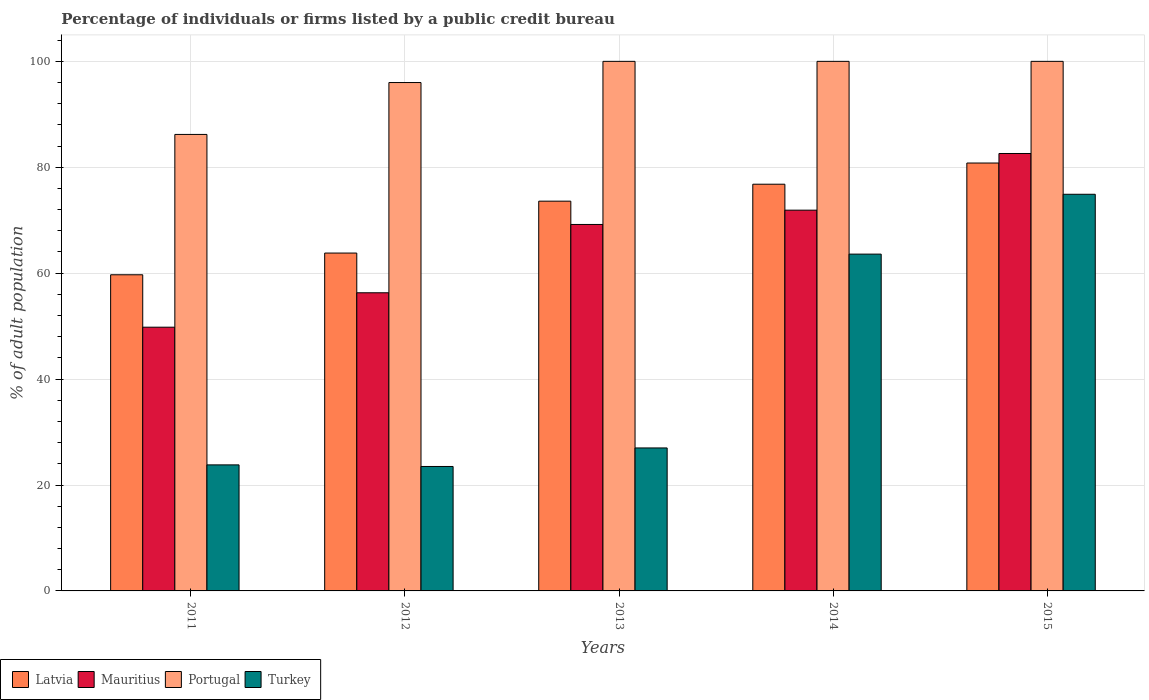How many different coloured bars are there?
Your response must be concise. 4. Are the number of bars per tick equal to the number of legend labels?
Ensure brevity in your answer.  Yes. Are the number of bars on each tick of the X-axis equal?
Your response must be concise. Yes. How many bars are there on the 3rd tick from the left?
Offer a terse response. 4. What is the label of the 1st group of bars from the left?
Your answer should be compact. 2011. In how many cases, is the number of bars for a given year not equal to the number of legend labels?
Provide a short and direct response. 0. What is the percentage of population listed by a public credit bureau in Turkey in 2014?
Your answer should be compact. 63.6. Across all years, what is the minimum percentage of population listed by a public credit bureau in Turkey?
Your response must be concise. 23.5. In which year was the percentage of population listed by a public credit bureau in Turkey maximum?
Give a very brief answer. 2015. In which year was the percentage of population listed by a public credit bureau in Turkey minimum?
Offer a very short reply. 2012. What is the total percentage of population listed by a public credit bureau in Mauritius in the graph?
Your response must be concise. 329.8. What is the difference between the percentage of population listed by a public credit bureau in Portugal in 2013 and that in 2015?
Give a very brief answer. 0. What is the difference between the percentage of population listed by a public credit bureau in Turkey in 2011 and the percentage of population listed by a public credit bureau in Mauritius in 2014?
Your answer should be compact. -48.1. What is the average percentage of population listed by a public credit bureau in Latvia per year?
Keep it short and to the point. 70.94. In the year 2012, what is the difference between the percentage of population listed by a public credit bureau in Latvia and percentage of population listed by a public credit bureau in Portugal?
Give a very brief answer. -32.2. What is the ratio of the percentage of population listed by a public credit bureau in Latvia in 2014 to that in 2015?
Offer a terse response. 0.95. What is the difference between the highest and the second highest percentage of population listed by a public credit bureau in Mauritius?
Provide a succinct answer. 10.7. What is the difference between the highest and the lowest percentage of population listed by a public credit bureau in Portugal?
Keep it short and to the point. 13.8. Is it the case that in every year, the sum of the percentage of population listed by a public credit bureau in Mauritius and percentage of population listed by a public credit bureau in Latvia is greater than the sum of percentage of population listed by a public credit bureau in Turkey and percentage of population listed by a public credit bureau in Portugal?
Your response must be concise. No. What does the 3rd bar from the left in 2013 represents?
Offer a very short reply. Portugal. What does the 2nd bar from the right in 2013 represents?
Your answer should be compact. Portugal. How many bars are there?
Your answer should be very brief. 20. Are all the bars in the graph horizontal?
Offer a terse response. No. What is the difference between two consecutive major ticks on the Y-axis?
Ensure brevity in your answer.  20. Are the values on the major ticks of Y-axis written in scientific E-notation?
Keep it short and to the point. No. How are the legend labels stacked?
Offer a terse response. Horizontal. What is the title of the graph?
Keep it short and to the point. Percentage of individuals or firms listed by a public credit bureau. Does "Central African Republic" appear as one of the legend labels in the graph?
Offer a very short reply. No. What is the label or title of the X-axis?
Offer a terse response. Years. What is the label or title of the Y-axis?
Offer a very short reply. % of adult population. What is the % of adult population in Latvia in 2011?
Your answer should be compact. 59.7. What is the % of adult population in Mauritius in 2011?
Make the answer very short. 49.8. What is the % of adult population in Portugal in 2011?
Offer a terse response. 86.2. What is the % of adult population in Turkey in 2011?
Your answer should be compact. 23.8. What is the % of adult population of Latvia in 2012?
Provide a short and direct response. 63.8. What is the % of adult population in Mauritius in 2012?
Provide a short and direct response. 56.3. What is the % of adult population in Portugal in 2012?
Provide a short and direct response. 96. What is the % of adult population of Latvia in 2013?
Provide a succinct answer. 73.6. What is the % of adult population in Mauritius in 2013?
Give a very brief answer. 69.2. What is the % of adult population of Latvia in 2014?
Your answer should be very brief. 76.8. What is the % of adult population of Mauritius in 2014?
Your answer should be very brief. 71.9. What is the % of adult population in Portugal in 2014?
Offer a very short reply. 100. What is the % of adult population of Turkey in 2014?
Provide a short and direct response. 63.6. What is the % of adult population in Latvia in 2015?
Your answer should be compact. 80.8. What is the % of adult population in Mauritius in 2015?
Your answer should be very brief. 82.6. What is the % of adult population in Portugal in 2015?
Keep it short and to the point. 100. What is the % of adult population in Turkey in 2015?
Your answer should be compact. 74.9. Across all years, what is the maximum % of adult population of Latvia?
Offer a terse response. 80.8. Across all years, what is the maximum % of adult population of Mauritius?
Your response must be concise. 82.6. Across all years, what is the maximum % of adult population in Turkey?
Ensure brevity in your answer.  74.9. Across all years, what is the minimum % of adult population of Latvia?
Your answer should be compact. 59.7. Across all years, what is the minimum % of adult population of Mauritius?
Offer a very short reply. 49.8. Across all years, what is the minimum % of adult population in Portugal?
Your answer should be compact. 86.2. What is the total % of adult population of Latvia in the graph?
Give a very brief answer. 354.7. What is the total % of adult population in Mauritius in the graph?
Keep it short and to the point. 329.8. What is the total % of adult population in Portugal in the graph?
Give a very brief answer. 482.2. What is the total % of adult population of Turkey in the graph?
Keep it short and to the point. 212.8. What is the difference between the % of adult population in Turkey in 2011 and that in 2012?
Keep it short and to the point. 0.3. What is the difference between the % of adult population of Latvia in 2011 and that in 2013?
Your answer should be compact. -13.9. What is the difference between the % of adult population of Mauritius in 2011 and that in 2013?
Offer a terse response. -19.4. What is the difference between the % of adult population in Turkey in 2011 and that in 2013?
Give a very brief answer. -3.2. What is the difference between the % of adult population of Latvia in 2011 and that in 2014?
Your answer should be very brief. -17.1. What is the difference between the % of adult population in Mauritius in 2011 and that in 2014?
Provide a succinct answer. -22.1. What is the difference between the % of adult population in Portugal in 2011 and that in 2014?
Keep it short and to the point. -13.8. What is the difference between the % of adult population in Turkey in 2011 and that in 2014?
Give a very brief answer. -39.8. What is the difference between the % of adult population of Latvia in 2011 and that in 2015?
Your answer should be compact. -21.1. What is the difference between the % of adult population of Mauritius in 2011 and that in 2015?
Your answer should be very brief. -32.8. What is the difference between the % of adult population in Portugal in 2011 and that in 2015?
Give a very brief answer. -13.8. What is the difference between the % of adult population of Turkey in 2011 and that in 2015?
Offer a very short reply. -51.1. What is the difference between the % of adult population in Latvia in 2012 and that in 2014?
Offer a terse response. -13. What is the difference between the % of adult population in Mauritius in 2012 and that in 2014?
Make the answer very short. -15.6. What is the difference between the % of adult population in Portugal in 2012 and that in 2014?
Provide a short and direct response. -4. What is the difference between the % of adult population in Turkey in 2012 and that in 2014?
Make the answer very short. -40.1. What is the difference between the % of adult population in Mauritius in 2012 and that in 2015?
Make the answer very short. -26.3. What is the difference between the % of adult population in Turkey in 2012 and that in 2015?
Make the answer very short. -51.4. What is the difference between the % of adult population of Portugal in 2013 and that in 2014?
Give a very brief answer. 0. What is the difference between the % of adult population of Turkey in 2013 and that in 2014?
Your response must be concise. -36.6. What is the difference between the % of adult population of Latvia in 2013 and that in 2015?
Provide a short and direct response. -7.2. What is the difference between the % of adult population of Turkey in 2013 and that in 2015?
Your answer should be very brief. -47.9. What is the difference between the % of adult population in Portugal in 2014 and that in 2015?
Offer a terse response. 0. What is the difference between the % of adult population of Latvia in 2011 and the % of adult population of Mauritius in 2012?
Provide a succinct answer. 3.4. What is the difference between the % of adult population in Latvia in 2011 and the % of adult population in Portugal in 2012?
Provide a succinct answer. -36.3. What is the difference between the % of adult population of Latvia in 2011 and the % of adult population of Turkey in 2012?
Offer a very short reply. 36.2. What is the difference between the % of adult population in Mauritius in 2011 and the % of adult population in Portugal in 2012?
Keep it short and to the point. -46.2. What is the difference between the % of adult population in Mauritius in 2011 and the % of adult population in Turkey in 2012?
Make the answer very short. 26.3. What is the difference between the % of adult population in Portugal in 2011 and the % of adult population in Turkey in 2012?
Keep it short and to the point. 62.7. What is the difference between the % of adult population in Latvia in 2011 and the % of adult population in Mauritius in 2013?
Offer a terse response. -9.5. What is the difference between the % of adult population in Latvia in 2011 and the % of adult population in Portugal in 2013?
Your answer should be very brief. -40.3. What is the difference between the % of adult population in Latvia in 2011 and the % of adult population in Turkey in 2013?
Ensure brevity in your answer.  32.7. What is the difference between the % of adult population in Mauritius in 2011 and the % of adult population in Portugal in 2013?
Offer a terse response. -50.2. What is the difference between the % of adult population of Mauritius in 2011 and the % of adult population of Turkey in 2013?
Your answer should be compact. 22.8. What is the difference between the % of adult population of Portugal in 2011 and the % of adult population of Turkey in 2013?
Provide a short and direct response. 59.2. What is the difference between the % of adult population in Latvia in 2011 and the % of adult population in Mauritius in 2014?
Your answer should be very brief. -12.2. What is the difference between the % of adult population in Latvia in 2011 and the % of adult population in Portugal in 2014?
Your response must be concise. -40.3. What is the difference between the % of adult population of Mauritius in 2011 and the % of adult population of Portugal in 2014?
Make the answer very short. -50.2. What is the difference between the % of adult population of Portugal in 2011 and the % of adult population of Turkey in 2014?
Your response must be concise. 22.6. What is the difference between the % of adult population in Latvia in 2011 and the % of adult population in Mauritius in 2015?
Your response must be concise. -22.9. What is the difference between the % of adult population of Latvia in 2011 and the % of adult population of Portugal in 2015?
Give a very brief answer. -40.3. What is the difference between the % of adult population of Latvia in 2011 and the % of adult population of Turkey in 2015?
Offer a terse response. -15.2. What is the difference between the % of adult population of Mauritius in 2011 and the % of adult population of Portugal in 2015?
Provide a succinct answer. -50.2. What is the difference between the % of adult population of Mauritius in 2011 and the % of adult population of Turkey in 2015?
Your answer should be compact. -25.1. What is the difference between the % of adult population in Latvia in 2012 and the % of adult population in Mauritius in 2013?
Provide a succinct answer. -5.4. What is the difference between the % of adult population in Latvia in 2012 and the % of adult population in Portugal in 2013?
Your answer should be very brief. -36.2. What is the difference between the % of adult population in Latvia in 2012 and the % of adult population in Turkey in 2013?
Provide a succinct answer. 36.8. What is the difference between the % of adult population in Mauritius in 2012 and the % of adult population in Portugal in 2013?
Provide a succinct answer. -43.7. What is the difference between the % of adult population of Mauritius in 2012 and the % of adult population of Turkey in 2013?
Provide a succinct answer. 29.3. What is the difference between the % of adult population of Latvia in 2012 and the % of adult population of Portugal in 2014?
Provide a succinct answer. -36.2. What is the difference between the % of adult population in Latvia in 2012 and the % of adult population in Turkey in 2014?
Offer a very short reply. 0.2. What is the difference between the % of adult population of Mauritius in 2012 and the % of adult population of Portugal in 2014?
Provide a short and direct response. -43.7. What is the difference between the % of adult population of Portugal in 2012 and the % of adult population of Turkey in 2014?
Your answer should be very brief. 32.4. What is the difference between the % of adult population of Latvia in 2012 and the % of adult population of Mauritius in 2015?
Your response must be concise. -18.8. What is the difference between the % of adult population of Latvia in 2012 and the % of adult population of Portugal in 2015?
Your answer should be compact. -36.2. What is the difference between the % of adult population of Mauritius in 2012 and the % of adult population of Portugal in 2015?
Make the answer very short. -43.7. What is the difference between the % of adult population in Mauritius in 2012 and the % of adult population in Turkey in 2015?
Make the answer very short. -18.6. What is the difference between the % of adult population of Portugal in 2012 and the % of adult population of Turkey in 2015?
Your answer should be very brief. 21.1. What is the difference between the % of adult population in Latvia in 2013 and the % of adult population in Portugal in 2014?
Offer a very short reply. -26.4. What is the difference between the % of adult population of Latvia in 2013 and the % of adult population of Turkey in 2014?
Provide a short and direct response. 10. What is the difference between the % of adult population in Mauritius in 2013 and the % of adult population in Portugal in 2014?
Keep it short and to the point. -30.8. What is the difference between the % of adult population of Mauritius in 2013 and the % of adult population of Turkey in 2014?
Your response must be concise. 5.6. What is the difference between the % of adult population in Portugal in 2013 and the % of adult population in Turkey in 2014?
Give a very brief answer. 36.4. What is the difference between the % of adult population of Latvia in 2013 and the % of adult population of Portugal in 2015?
Offer a very short reply. -26.4. What is the difference between the % of adult population in Latvia in 2013 and the % of adult population in Turkey in 2015?
Offer a very short reply. -1.3. What is the difference between the % of adult population in Mauritius in 2013 and the % of adult population in Portugal in 2015?
Keep it short and to the point. -30.8. What is the difference between the % of adult population of Portugal in 2013 and the % of adult population of Turkey in 2015?
Give a very brief answer. 25.1. What is the difference between the % of adult population in Latvia in 2014 and the % of adult population in Portugal in 2015?
Ensure brevity in your answer.  -23.2. What is the difference between the % of adult population of Latvia in 2014 and the % of adult population of Turkey in 2015?
Provide a short and direct response. 1.9. What is the difference between the % of adult population in Mauritius in 2014 and the % of adult population in Portugal in 2015?
Provide a short and direct response. -28.1. What is the difference between the % of adult population of Mauritius in 2014 and the % of adult population of Turkey in 2015?
Your answer should be compact. -3. What is the difference between the % of adult population of Portugal in 2014 and the % of adult population of Turkey in 2015?
Offer a very short reply. 25.1. What is the average % of adult population in Latvia per year?
Your answer should be very brief. 70.94. What is the average % of adult population in Mauritius per year?
Make the answer very short. 65.96. What is the average % of adult population in Portugal per year?
Your answer should be very brief. 96.44. What is the average % of adult population in Turkey per year?
Your answer should be very brief. 42.56. In the year 2011, what is the difference between the % of adult population in Latvia and % of adult population in Mauritius?
Give a very brief answer. 9.9. In the year 2011, what is the difference between the % of adult population of Latvia and % of adult population of Portugal?
Give a very brief answer. -26.5. In the year 2011, what is the difference between the % of adult population in Latvia and % of adult population in Turkey?
Offer a very short reply. 35.9. In the year 2011, what is the difference between the % of adult population of Mauritius and % of adult population of Portugal?
Offer a terse response. -36.4. In the year 2011, what is the difference between the % of adult population of Portugal and % of adult population of Turkey?
Your answer should be very brief. 62.4. In the year 2012, what is the difference between the % of adult population of Latvia and % of adult population of Mauritius?
Offer a very short reply. 7.5. In the year 2012, what is the difference between the % of adult population in Latvia and % of adult population in Portugal?
Offer a terse response. -32.2. In the year 2012, what is the difference between the % of adult population in Latvia and % of adult population in Turkey?
Keep it short and to the point. 40.3. In the year 2012, what is the difference between the % of adult population in Mauritius and % of adult population in Portugal?
Ensure brevity in your answer.  -39.7. In the year 2012, what is the difference between the % of adult population in Mauritius and % of adult population in Turkey?
Provide a succinct answer. 32.8. In the year 2012, what is the difference between the % of adult population in Portugal and % of adult population in Turkey?
Provide a succinct answer. 72.5. In the year 2013, what is the difference between the % of adult population in Latvia and % of adult population in Portugal?
Keep it short and to the point. -26.4. In the year 2013, what is the difference between the % of adult population of Latvia and % of adult population of Turkey?
Offer a very short reply. 46.6. In the year 2013, what is the difference between the % of adult population of Mauritius and % of adult population of Portugal?
Ensure brevity in your answer.  -30.8. In the year 2013, what is the difference between the % of adult population of Mauritius and % of adult population of Turkey?
Make the answer very short. 42.2. In the year 2014, what is the difference between the % of adult population in Latvia and % of adult population in Mauritius?
Keep it short and to the point. 4.9. In the year 2014, what is the difference between the % of adult population in Latvia and % of adult population in Portugal?
Keep it short and to the point. -23.2. In the year 2014, what is the difference between the % of adult population of Mauritius and % of adult population of Portugal?
Give a very brief answer. -28.1. In the year 2014, what is the difference between the % of adult population in Mauritius and % of adult population in Turkey?
Your answer should be compact. 8.3. In the year 2014, what is the difference between the % of adult population of Portugal and % of adult population of Turkey?
Your answer should be compact. 36.4. In the year 2015, what is the difference between the % of adult population in Latvia and % of adult population in Portugal?
Ensure brevity in your answer.  -19.2. In the year 2015, what is the difference between the % of adult population of Latvia and % of adult population of Turkey?
Provide a short and direct response. 5.9. In the year 2015, what is the difference between the % of adult population of Mauritius and % of adult population of Portugal?
Keep it short and to the point. -17.4. In the year 2015, what is the difference between the % of adult population in Portugal and % of adult population in Turkey?
Keep it short and to the point. 25.1. What is the ratio of the % of adult population of Latvia in 2011 to that in 2012?
Your response must be concise. 0.94. What is the ratio of the % of adult population of Mauritius in 2011 to that in 2012?
Your response must be concise. 0.88. What is the ratio of the % of adult population of Portugal in 2011 to that in 2012?
Provide a short and direct response. 0.9. What is the ratio of the % of adult population of Turkey in 2011 to that in 2012?
Offer a terse response. 1.01. What is the ratio of the % of adult population of Latvia in 2011 to that in 2013?
Ensure brevity in your answer.  0.81. What is the ratio of the % of adult population of Mauritius in 2011 to that in 2013?
Your answer should be very brief. 0.72. What is the ratio of the % of adult population in Portugal in 2011 to that in 2013?
Keep it short and to the point. 0.86. What is the ratio of the % of adult population in Turkey in 2011 to that in 2013?
Give a very brief answer. 0.88. What is the ratio of the % of adult population of Latvia in 2011 to that in 2014?
Make the answer very short. 0.78. What is the ratio of the % of adult population in Mauritius in 2011 to that in 2014?
Your answer should be very brief. 0.69. What is the ratio of the % of adult population in Portugal in 2011 to that in 2014?
Provide a short and direct response. 0.86. What is the ratio of the % of adult population in Turkey in 2011 to that in 2014?
Ensure brevity in your answer.  0.37. What is the ratio of the % of adult population in Latvia in 2011 to that in 2015?
Give a very brief answer. 0.74. What is the ratio of the % of adult population in Mauritius in 2011 to that in 2015?
Give a very brief answer. 0.6. What is the ratio of the % of adult population in Portugal in 2011 to that in 2015?
Keep it short and to the point. 0.86. What is the ratio of the % of adult population in Turkey in 2011 to that in 2015?
Your answer should be compact. 0.32. What is the ratio of the % of adult population in Latvia in 2012 to that in 2013?
Provide a short and direct response. 0.87. What is the ratio of the % of adult population in Mauritius in 2012 to that in 2013?
Your answer should be compact. 0.81. What is the ratio of the % of adult population of Turkey in 2012 to that in 2013?
Offer a very short reply. 0.87. What is the ratio of the % of adult population in Latvia in 2012 to that in 2014?
Offer a very short reply. 0.83. What is the ratio of the % of adult population of Mauritius in 2012 to that in 2014?
Keep it short and to the point. 0.78. What is the ratio of the % of adult population in Portugal in 2012 to that in 2014?
Keep it short and to the point. 0.96. What is the ratio of the % of adult population of Turkey in 2012 to that in 2014?
Make the answer very short. 0.37. What is the ratio of the % of adult population in Latvia in 2012 to that in 2015?
Your answer should be compact. 0.79. What is the ratio of the % of adult population in Mauritius in 2012 to that in 2015?
Your response must be concise. 0.68. What is the ratio of the % of adult population in Portugal in 2012 to that in 2015?
Make the answer very short. 0.96. What is the ratio of the % of adult population in Turkey in 2012 to that in 2015?
Make the answer very short. 0.31. What is the ratio of the % of adult population of Mauritius in 2013 to that in 2014?
Ensure brevity in your answer.  0.96. What is the ratio of the % of adult population in Portugal in 2013 to that in 2014?
Your response must be concise. 1. What is the ratio of the % of adult population in Turkey in 2013 to that in 2014?
Keep it short and to the point. 0.42. What is the ratio of the % of adult population in Latvia in 2013 to that in 2015?
Your answer should be compact. 0.91. What is the ratio of the % of adult population in Mauritius in 2013 to that in 2015?
Your answer should be compact. 0.84. What is the ratio of the % of adult population of Portugal in 2013 to that in 2015?
Your answer should be very brief. 1. What is the ratio of the % of adult population in Turkey in 2013 to that in 2015?
Offer a very short reply. 0.36. What is the ratio of the % of adult population of Latvia in 2014 to that in 2015?
Your answer should be compact. 0.95. What is the ratio of the % of adult population of Mauritius in 2014 to that in 2015?
Keep it short and to the point. 0.87. What is the ratio of the % of adult population in Portugal in 2014 to that in 2015?
Offer a terse response. 1. What is the ratio of the % of adult population in Turkey in 2014 to that in 2015?
Provide a succinct answer. 0.85. What is the difference between the highest and the second highest % of adult population of Portugal?
Provide a short and direct response. 0. What is the difference between the highest and the second highest % of adult population in Turkey?
Your answer should be compact. 11.3. What is the difference between the highest and the lowest % of adult population in Latvia?
Your answer should be very brief. 21.1. What is the difference between the highest and the lowest % of adult population of Mauritius?
Provide a short and direct response. 32.8. What is the difference between the highest and the lowest % of adult population of Portugal?
Give a very brief answer. 13.8. What is the difference between the highest and the lowest % of adult population of Turkey?
Your answer should be very brief. 51.4. 